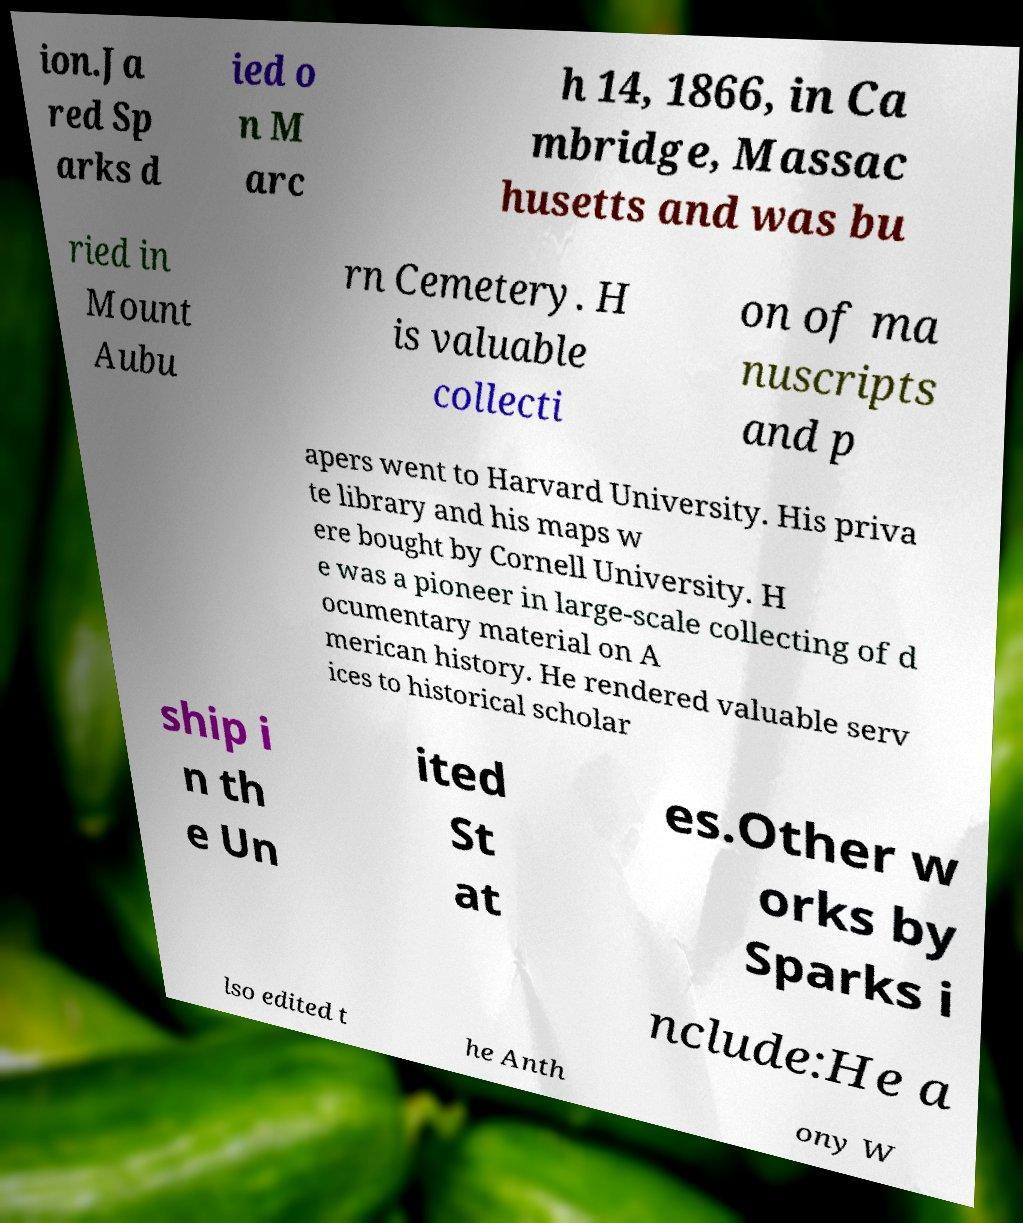Could you assist in decoding the text presented in this image and type it out clearly? ion.Ja red Sp arks d ied o n M arc h 14, 1866, in Ca mbridge, Massac husetts and was bu ried in Mount Aubu rn Cemetery. H is valuable collecti on of ma nuscripts and p apers went to Harvard University. His priva te library and his maps w ere bought by Cornell University. H e was a pioneer in large-scale collecting of d ocumentary material on A merican history. He rendered valuable serv ices to historical scholar ship i n th e Un ited St at es.Other w orks by Sparks i nclude:He a lso edited t he Anth ony W 